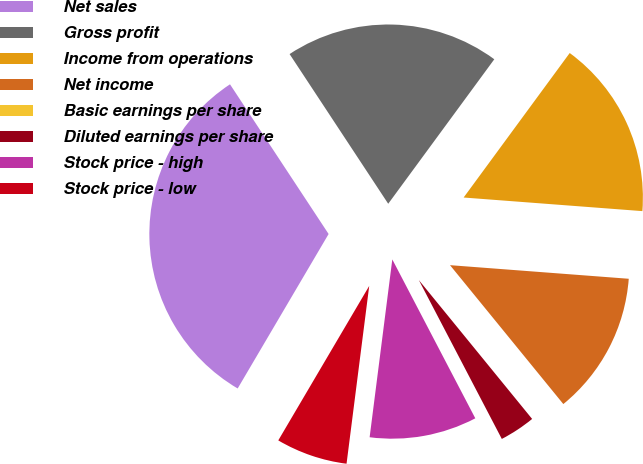Convert chart to OTSL. <chart><loc_0><loc_0><loc_500><loc_500><pie_chart><fcel>Net sales<fcel>Gross profit<fcel>Income from operations<fcel>Net income<fcel>Basic earnings per share<fcel>Diluted earnings per share<fcel>Stock price - high<fcel>Stock price - low<nl><fcel>32.26%<fcel>19.35%<fcel>16.13%<fcel>12.9%<fcel>0.0%<fcel>3.23%<fcel>9.68%<fcel>6.45%<nl></chart> 